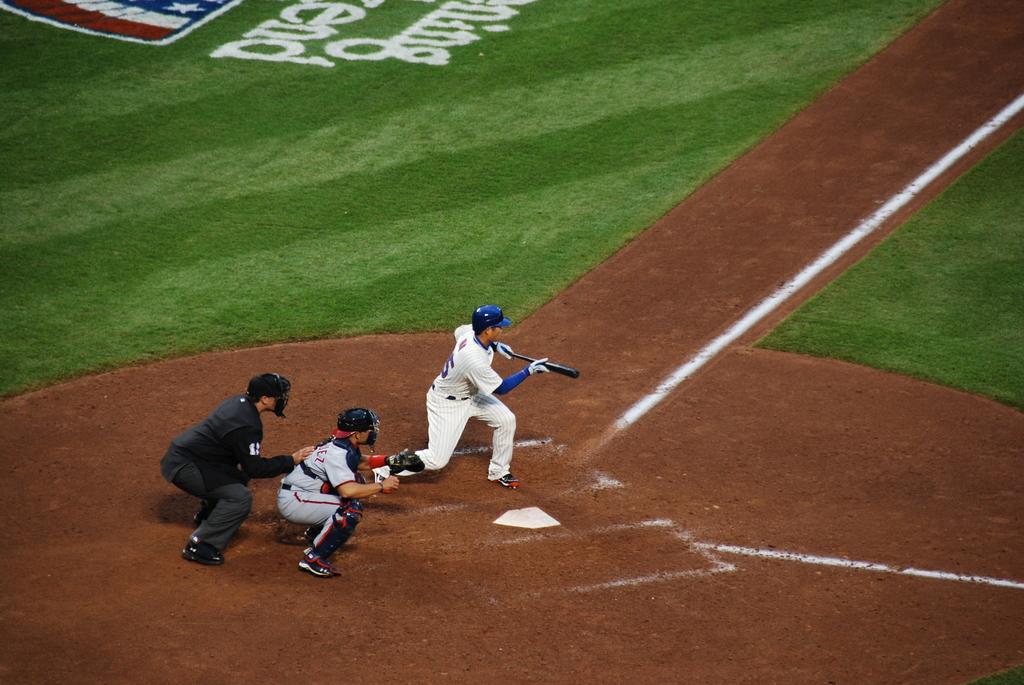Please provide a concise description of this image. In this picture we can observe three members in the baseball ground. One of them was holding a baseball bat and wearing blue color helmet. Two of them were wearing white color dress and the other guy was wearing black color dress. In the background there is a baseball ground. 